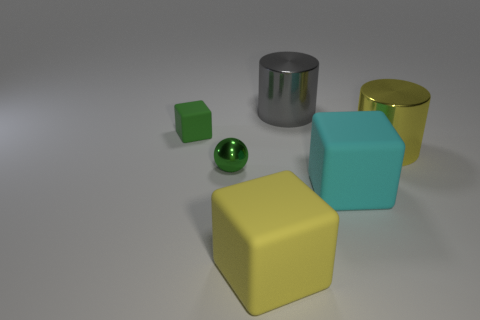What shape is the matte object that is the same color as the tiny shiny object?
Ensure brevity in your answer.  Cube. Is the size of the yellow cylinder the same as the yellow object that is in front of the yellow metal cylinder?
Provide a short and direct response. Yes. The cyan object that is the same shape as the yellow matte thing is what size?
Make the answer very short. Large. Is the size of the metal cylinder that is to the right of the big gray shiny cylinder the same as the matte block that is left of the large yellow rubber block?
Provide a succinct answer. No. What number of tiny objects are cylinders or gray metallic cylinders?
Provide a short and direct response. 0. What number of blocks are behind the small shiny ball and on the right side of the green matte block?
Give a very brief answer. 0. Do the yellow cylinder and the big cylinder on the left side of the cyan rubber object have the same material?
Provide a short and direct response. Yes. How many cyan objects are either small shiny spheres or large metal cylinders?
Provide a short and direct response. 0. Is there a brown rubber object of the same size as the green rubber block?
Your answer should be very brief. No. There is a yellow object that is to the right of the yellow thing that is to the left of the big shiny thing that is in front of the large gray metal cylinder; what is it made of?
Give a very brief answer. Metal. 